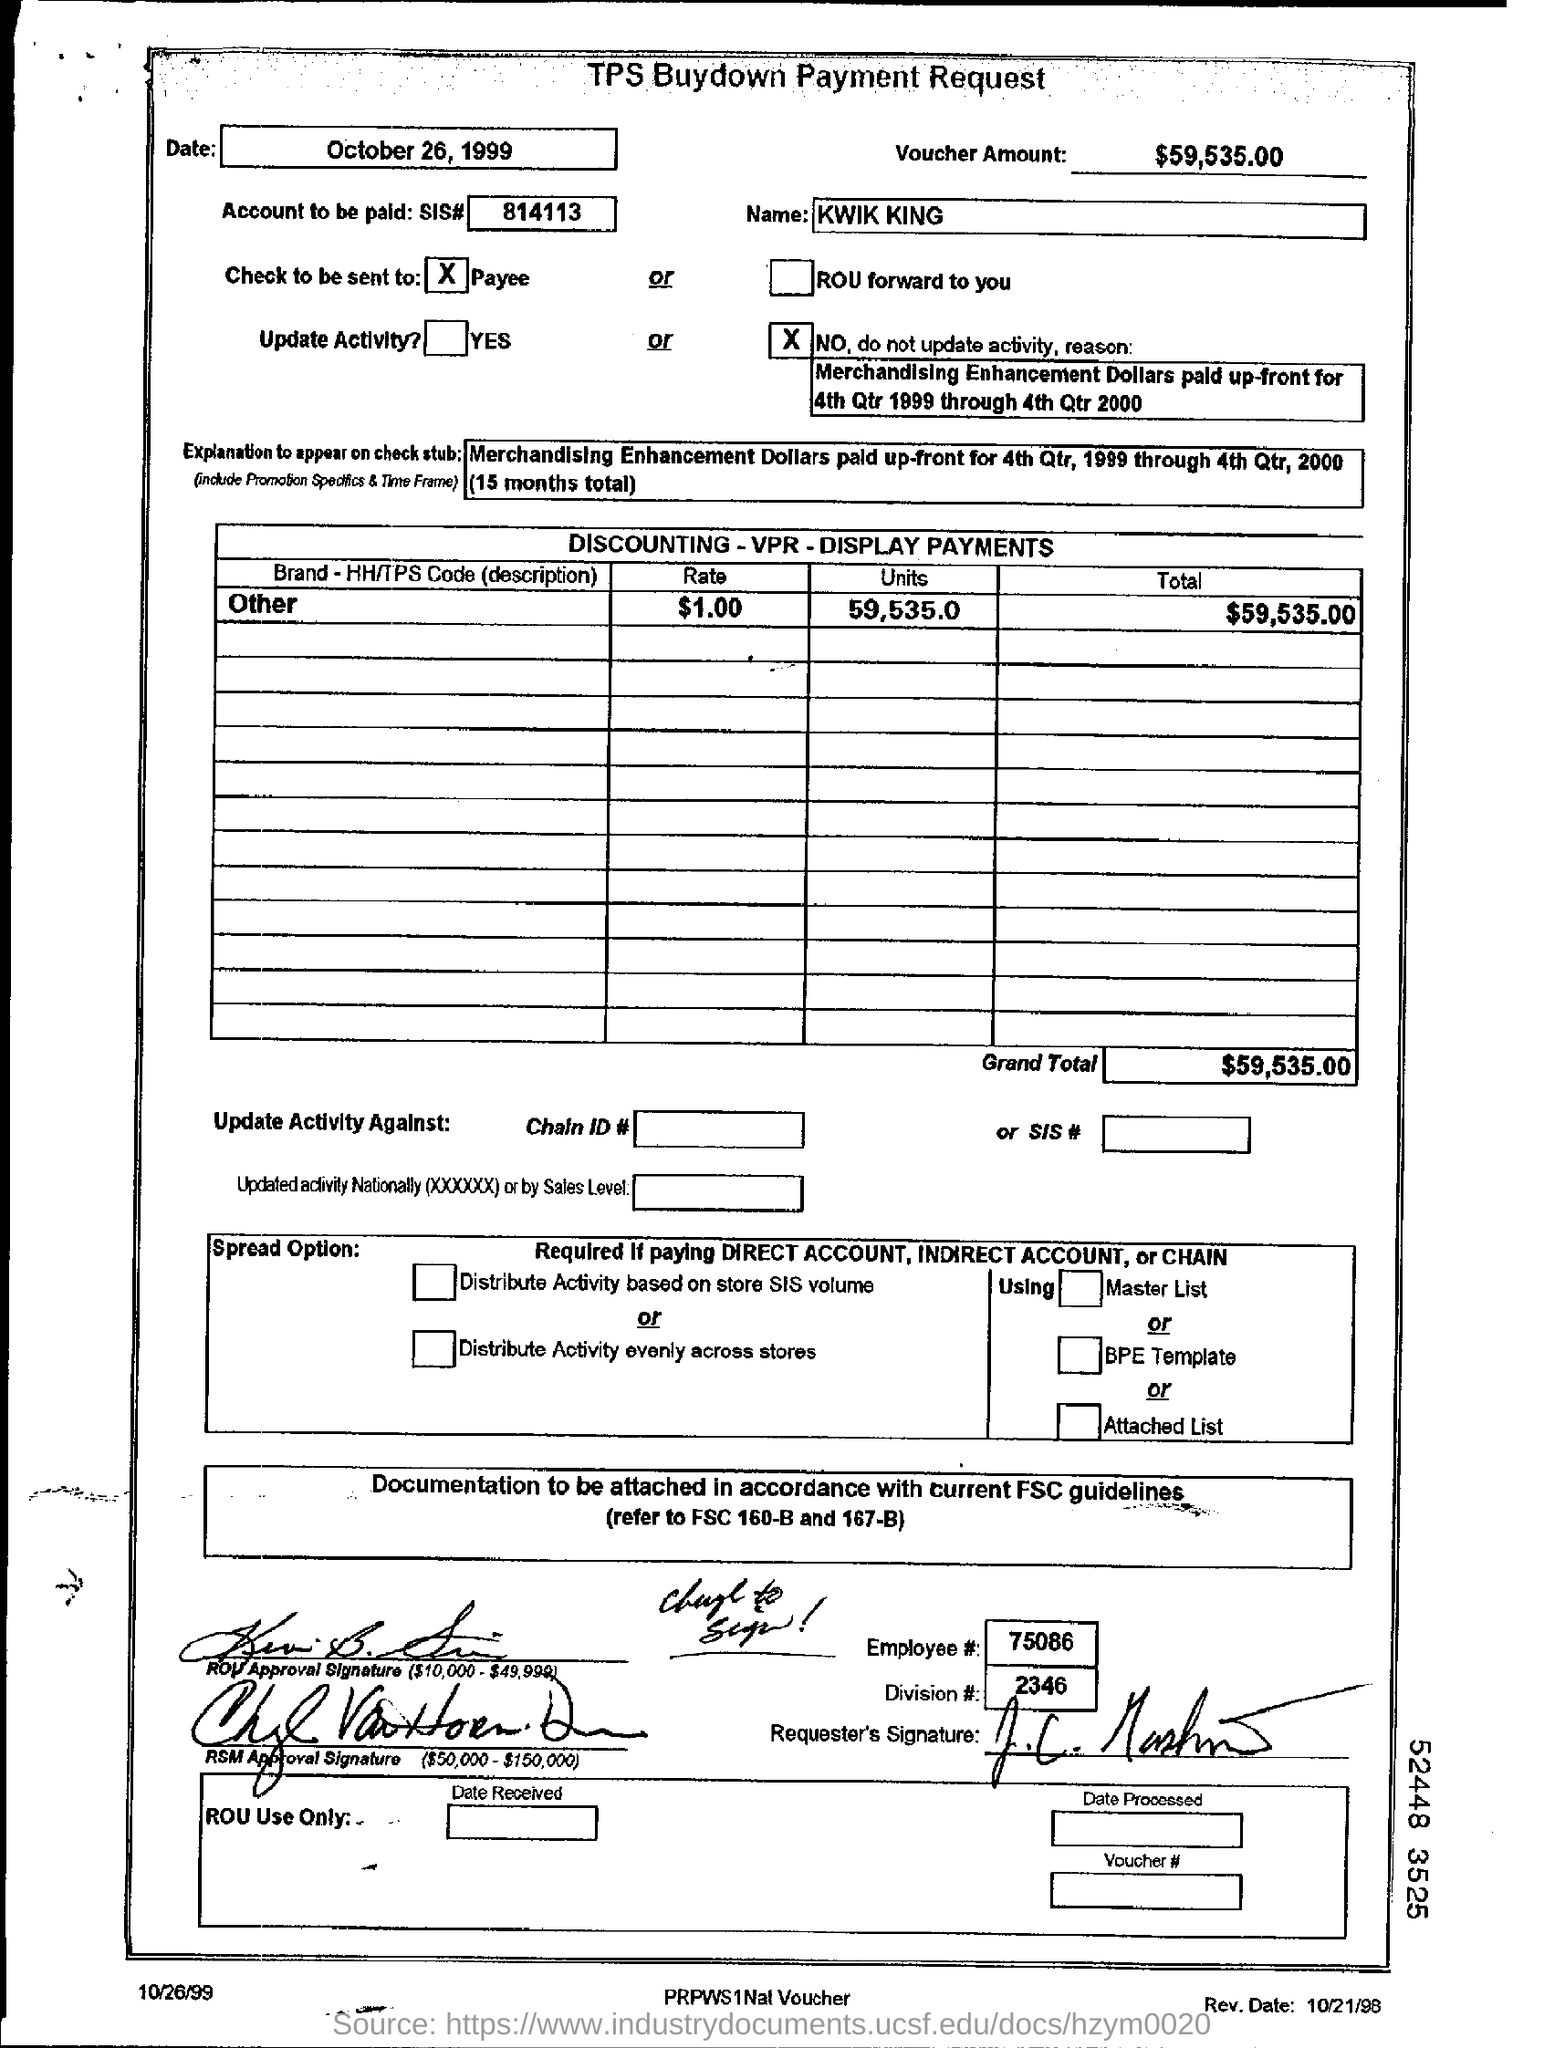What can we infer about the company 'KWIK KING' from this document? Based on the document, 'KWIK KING' seems to be the name of a business entity receiving a substantial payment of $59,535.00. This could imply that KWIK KING is involved in retail or merchandising activities, considering the context of merchandising enhancement dollars and display payments mentioned. 